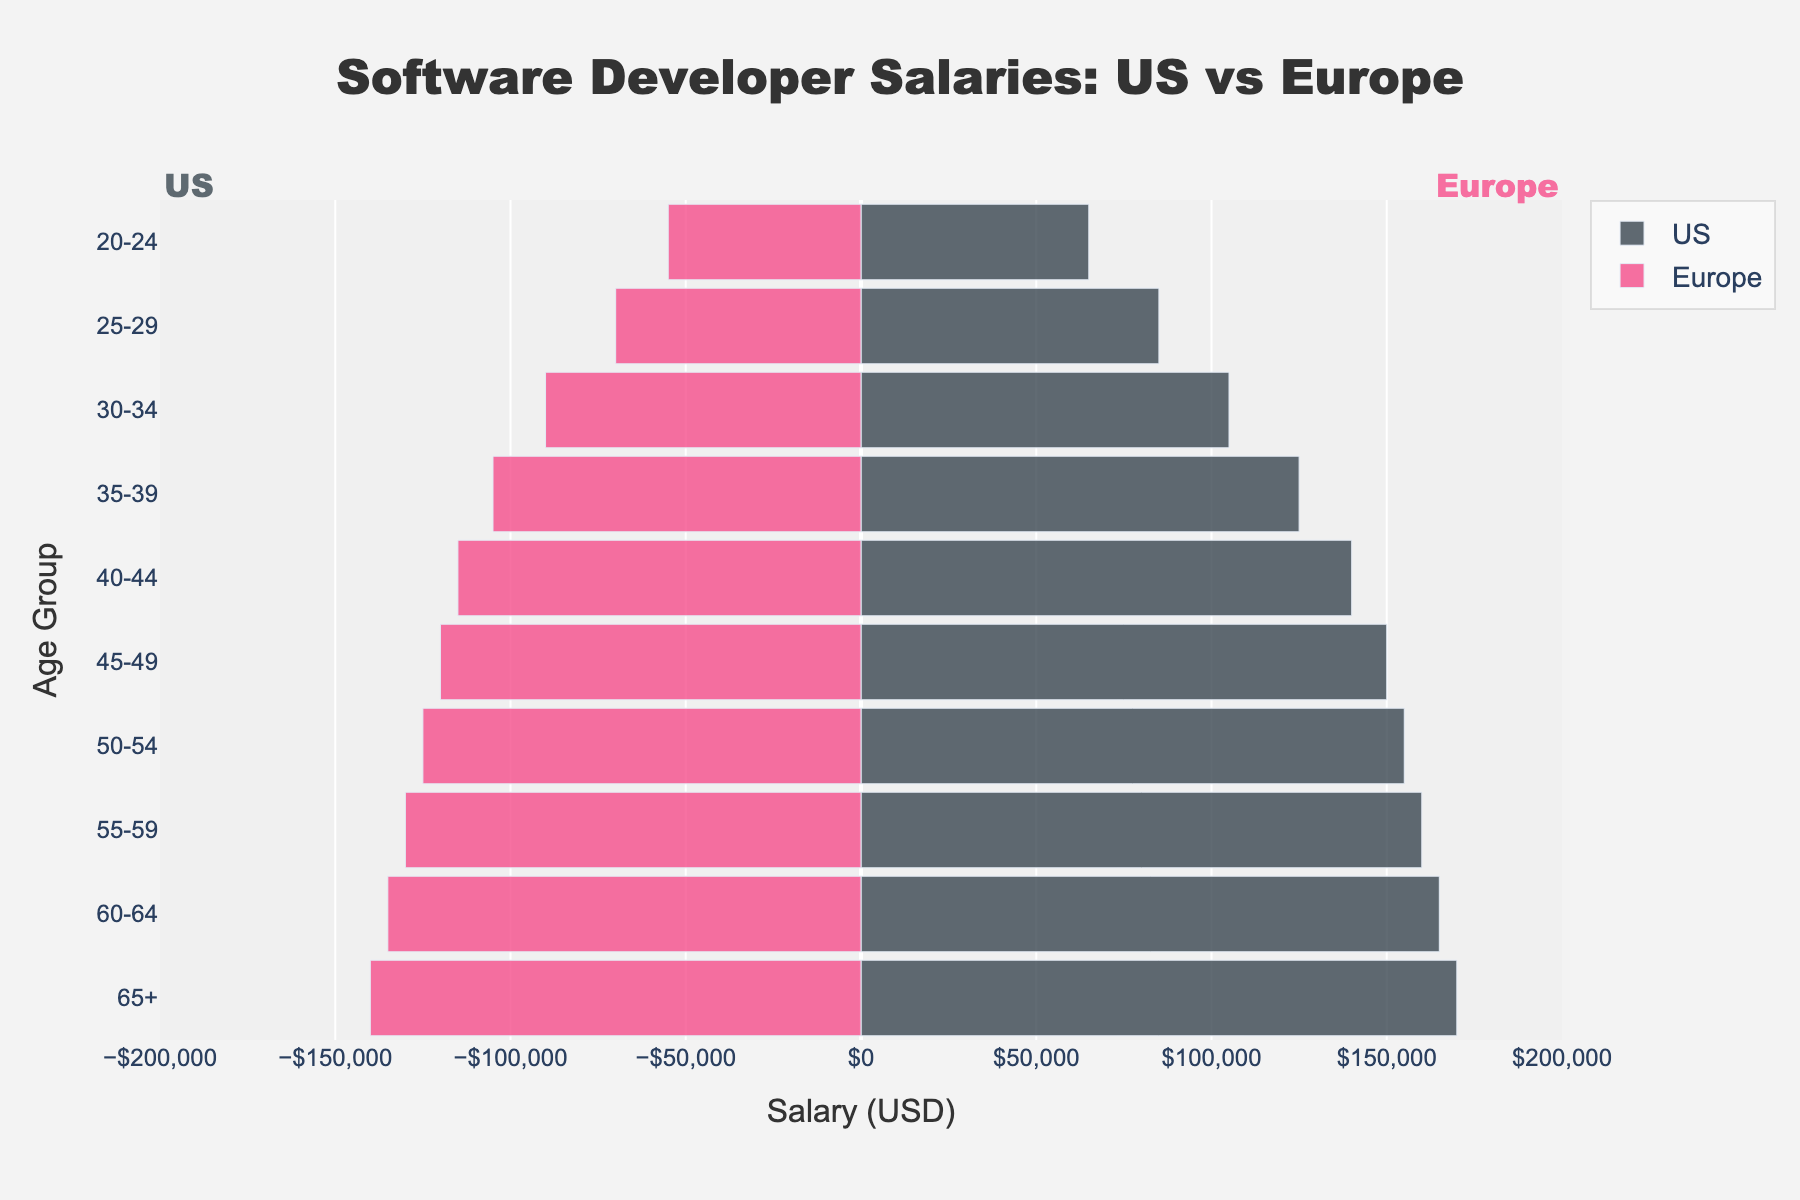What is the title of the figure? On the top of the figure, it clearly states the title: 'Software Developer Salaries: US vs Europe'.
Answer: Software Developer Salaries: US vs Europe How many age groups are there in the plot? The y-axis lists all the age groups, which count to a total number of 10 distinct age groups.
Answer: 10 What salary range is covered on the x-axis in the plot? The x-axis is marked from -200,000 to 200,000 USD, representing both negative and positive salary values for Europe and the US, respectively.
Answer: -200,000 to 200,000 USD In which age group do software developers earn the highest average salary in the US? Observing the bars for the US segment, the longest bar corresponds to the '65+' age group, indicative of the highest salary.
Answer: 65+ What is the salary difference between US and Europe for the age group 40-44? For the 40-44 age group, the US salary is 140,000 USD and the Europe salary is 115,000 USD. The difference is calculated by subtracting 115,000 from 140,000, which equals 25,000 USD.
Answer: 25,000 USD Which age group has a higher salary in the US compared to Europe by the largest margin? Comparing the length of the bars for all age groups, the '65+' age group shows the largest margin, with the US salary at 170,000 USD and the Europe salary at 140,000 USD, making the difference 30,000 USD.
Answer: 65+ What is the average salary for software developers in the US across all age groups in the plotted data? Adding up the US salaries in all age groups and dividing by the number of age groups: (65000+85000+105000+125000+140000+150000+155000+160000+165000+170000)/10 equates to an average of 122,500 USD.
Answer: 122,500 USD How do the salary patterns change with age in the US and Europe? Observing both sides of the plot, the general pattern shows an increase in salary with increasing age for both US and Europe, with the US salary incrementally higher in each successive age group compared to Europe.
Answer: Salary increases with age in both regions By how much does the salary of a 55-59-year-old software developer in the US exceed their counterpart in Europe? For the age group 55-59, the US salary is 160,000 USD and the Europe salary is 130,000 USD; thus, the US salary exceeds the Europe salary by 30,000 USD.
Answer: 30,000 USD Which age group has the smallest difference in salaries between the US and Europe? The smallest difference is observed in the '45-49' age group, where US salaries are 150,000 USD and Europe salaries are 120,000 USD, making the difference 30,000 USD (which is the smallest difference among all age groups since only two comparisons are within 30,000 USD range).
Answer: 45-49 